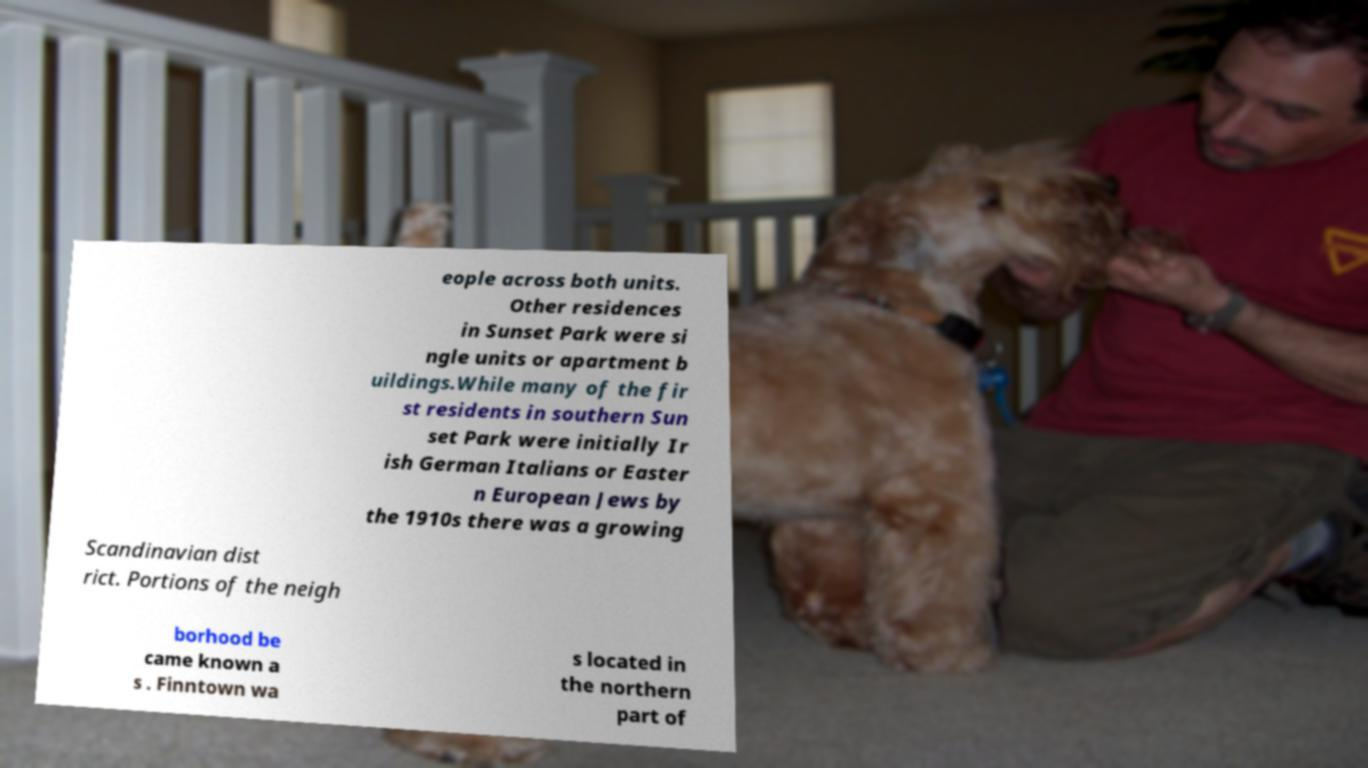What messages or text are displayed in this image? I need them in a readable, typed format. eople across both units. Other residences in Sunset Park were si ngle units or apartment b uildings.While many of the fir st residents in southern Sun set Park were initially Ir ish German Italians or Easter n European Jews by the 1910s there was a growing Scandinavian dist rict. Portions of the neigh borhood be came known a s . Finntown wa s located in the northern part of 